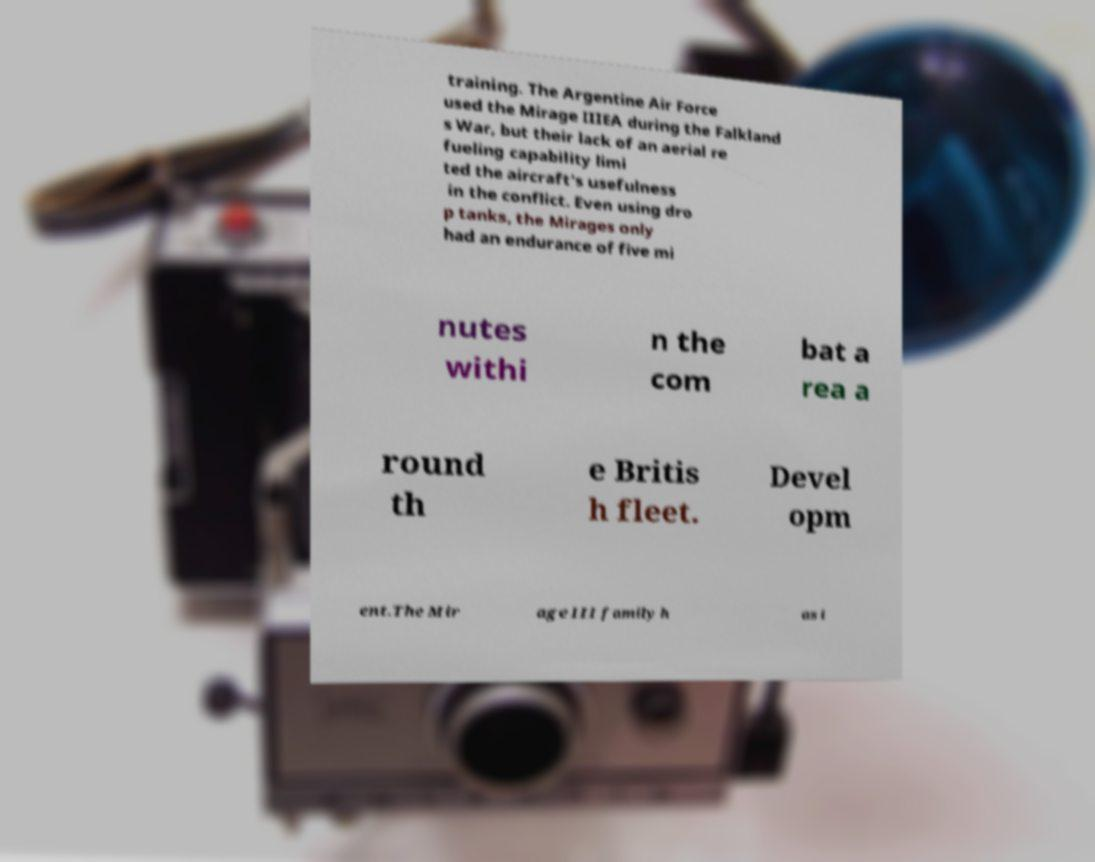Could you extract and type out the text from this image? training. The Argentine Air Force used the Mirage IIIEA during the Falkland s War, but their lack of an aerial re fueling capability limi ted the aircraft's usefulness in the conflict. Even using dro p tanks, the Mirages only had an endurance of five mi nutes withi n the com bat a rea a round th e Britis h fleet. Devel opm ent.The Mir age III family h as i 